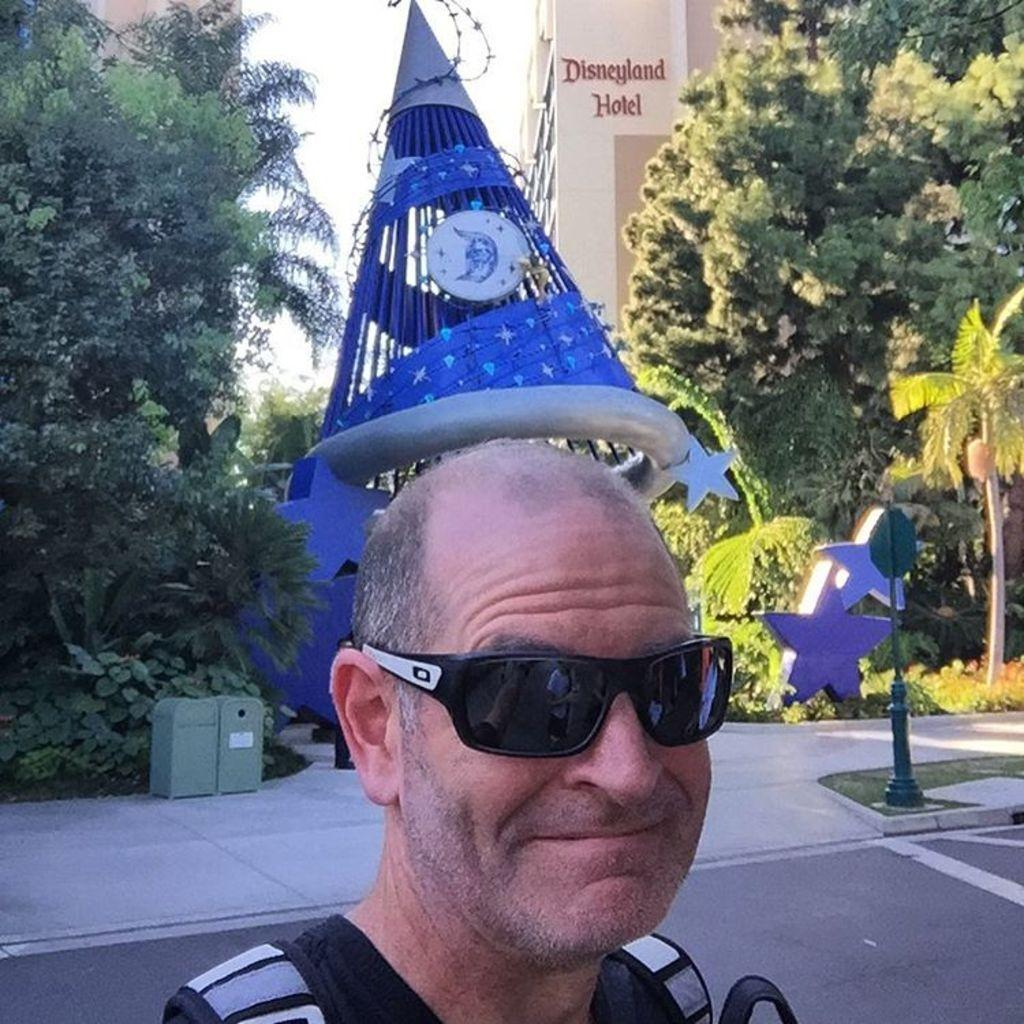Who is present in the image? There is a man in the image. What is the man doing in the image? The man is taking a selfie. What can be seen behind the man in the image? There is a sculpture behind the man. What type of natural environment is visible in the image? There are trees in the image. What type of structure is visible in the image? There is a building in the image. What type of string is being used to play the game in the image? There is no string or game present in the image; it features a man taking a selfie with a sculpture, trees, and a building in the background. 